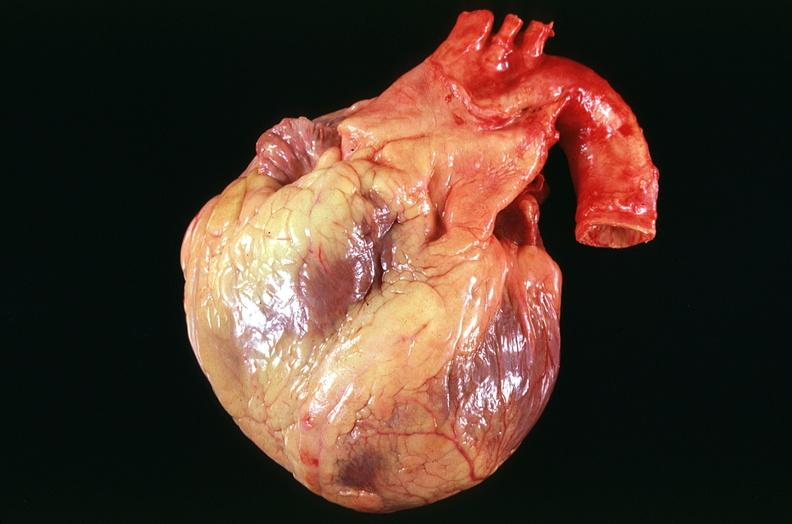how many vessel does this image show congestive heart failure, coronary artery disease?
Answer the question using a single word or phrase. Three 